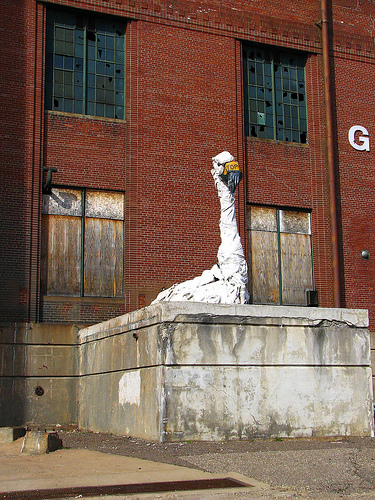<image>
Is there a statue to the left of the window? Yes. From this viewpoint, the statue is positioned to the left side relative to the window. 